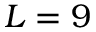Convert formula to latex. <formula><loc_0><loc_0><loc_500><loc_500>L = 9</formula> 